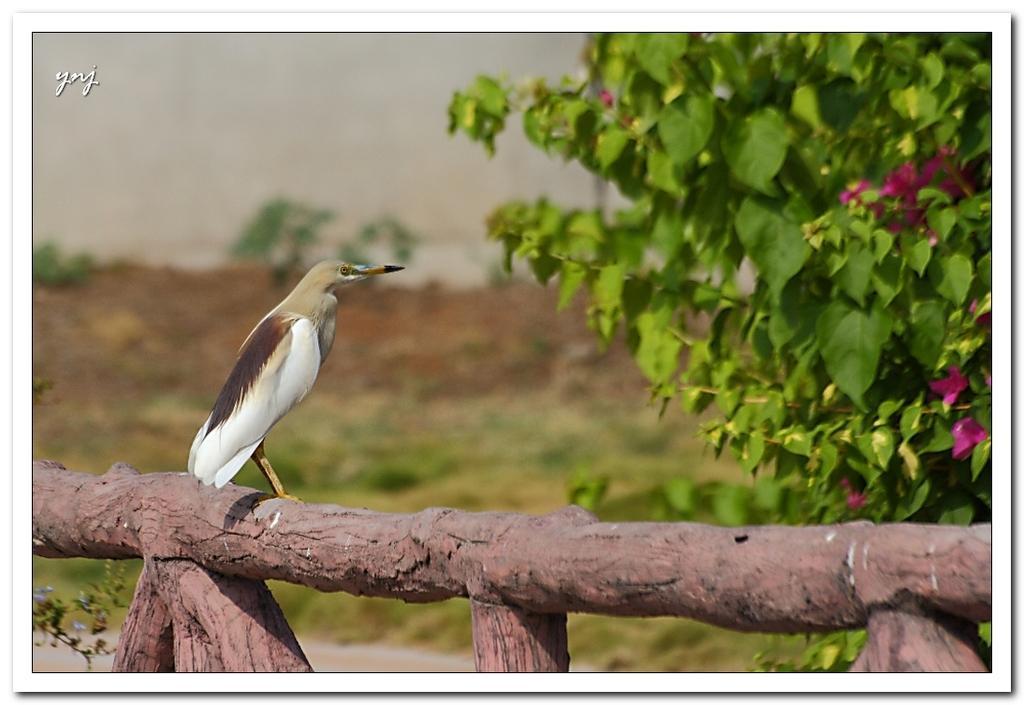Could you give a brief overview of what you see in this image? In this picture there is a bird who is standing on this wood. On the right I can see the flowers on the plant. In the background I can see the trees, mountain and grass. At the top I can see the sky. In the top left corner there is a watermark. 